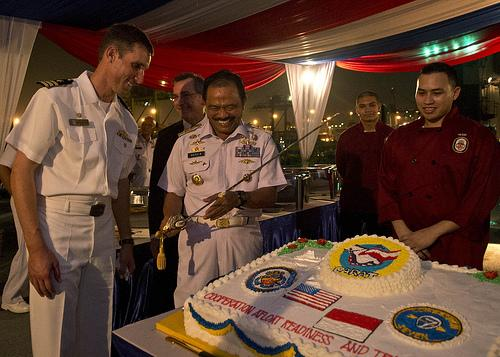Can you spot any accessories or items being held by anyone? A man is holding a gold sword with a yellow tassel. What is the sentiment conveyed by the image? The image evokes feelings of camaraderie and celebration. Count the number of men appearing in the image. There are at least four men in the image. Explain the roles of the individuals wearing red in the image. One man wearing a red uniform is a chef, and another individual wearing a red shirt is possibly a sous chef. List the objects that display red color in the image. A man's red shirt, red writing on the cake, American and Indonesian flags, and red and white fabric on the ceiling. What type of uniform are the two main subjects wearing? They are wearing white navy uniforms. Describe the background elements and their significance. The background features two lights, a curtain, and red and white fabric on the ceiling, which creates a festive and ceremonious atmosphere. What are the potential reasons for this gathering? Possible reasons include a ceremonial event, a military function, or a joint celebration between the U.S. and Indonesian navies. Briefly describe the cake's appearance and decoration. The cake is large and has white frosting adorned with U.S. and Indonesian flags, a U.S. Navy logo, red writing, and a handshake design. Identify the primary focus of the image in one sentence. The image shows people in uniforms, standing in front of a decorated cake on a table. 